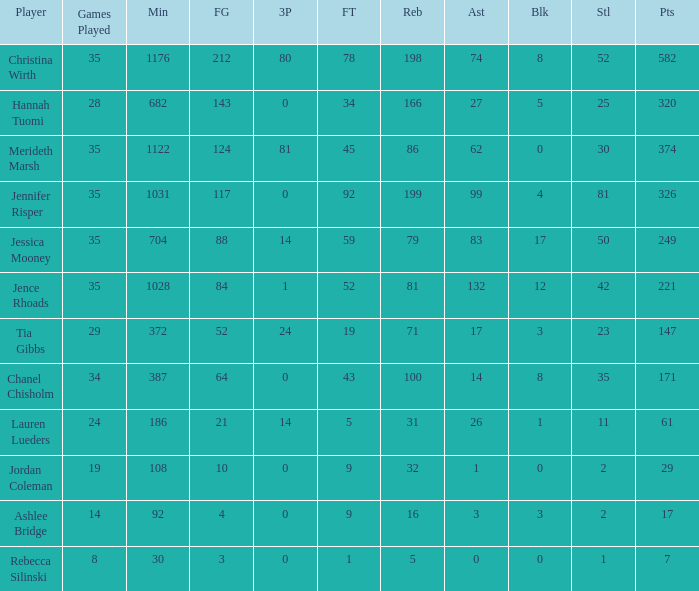What is the lowest number of games played by the player with 50 steals? 35.0. 